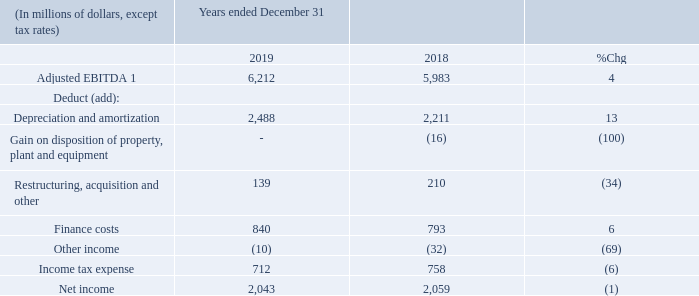INCOME TAX EXPENSE
Below is a summary of the difference between income tax expense computed by applying the statutory income tax rate to income before income tax expense and the actual income tax expense for the year.
Our effective income tax rate this year was 25.8% compared to 26.9% for 2018. The effective income tax rate for 2019 was lower than the statutory tax rate primarily as a result of a reduction to the Alberta corporate income tax rate over a four-year period.
What was the effective tax rate in 2019? 25.8%. What was the effective tax rate in 2018? 26.9%. What caused the decrease in effective tax rate from 2018 to 2019? Reduction to the alberta corporate income tax rate over a four-year period. What was the increase / (decrease) in Adjusted EBITDA from 2018 to 2019?
Answer scale should be: million. 6,212 - 5,983
Answer: 229. What was the average Depreciation and amortization?
Answer scale should be: million. (2,488 + 2,211) / 2
Answer: 2349.5. What was the increase / (decrease) in Finance cost from 2018 to 2019?
Answer scale should be: million. 840 - 793
Answer: 47. 